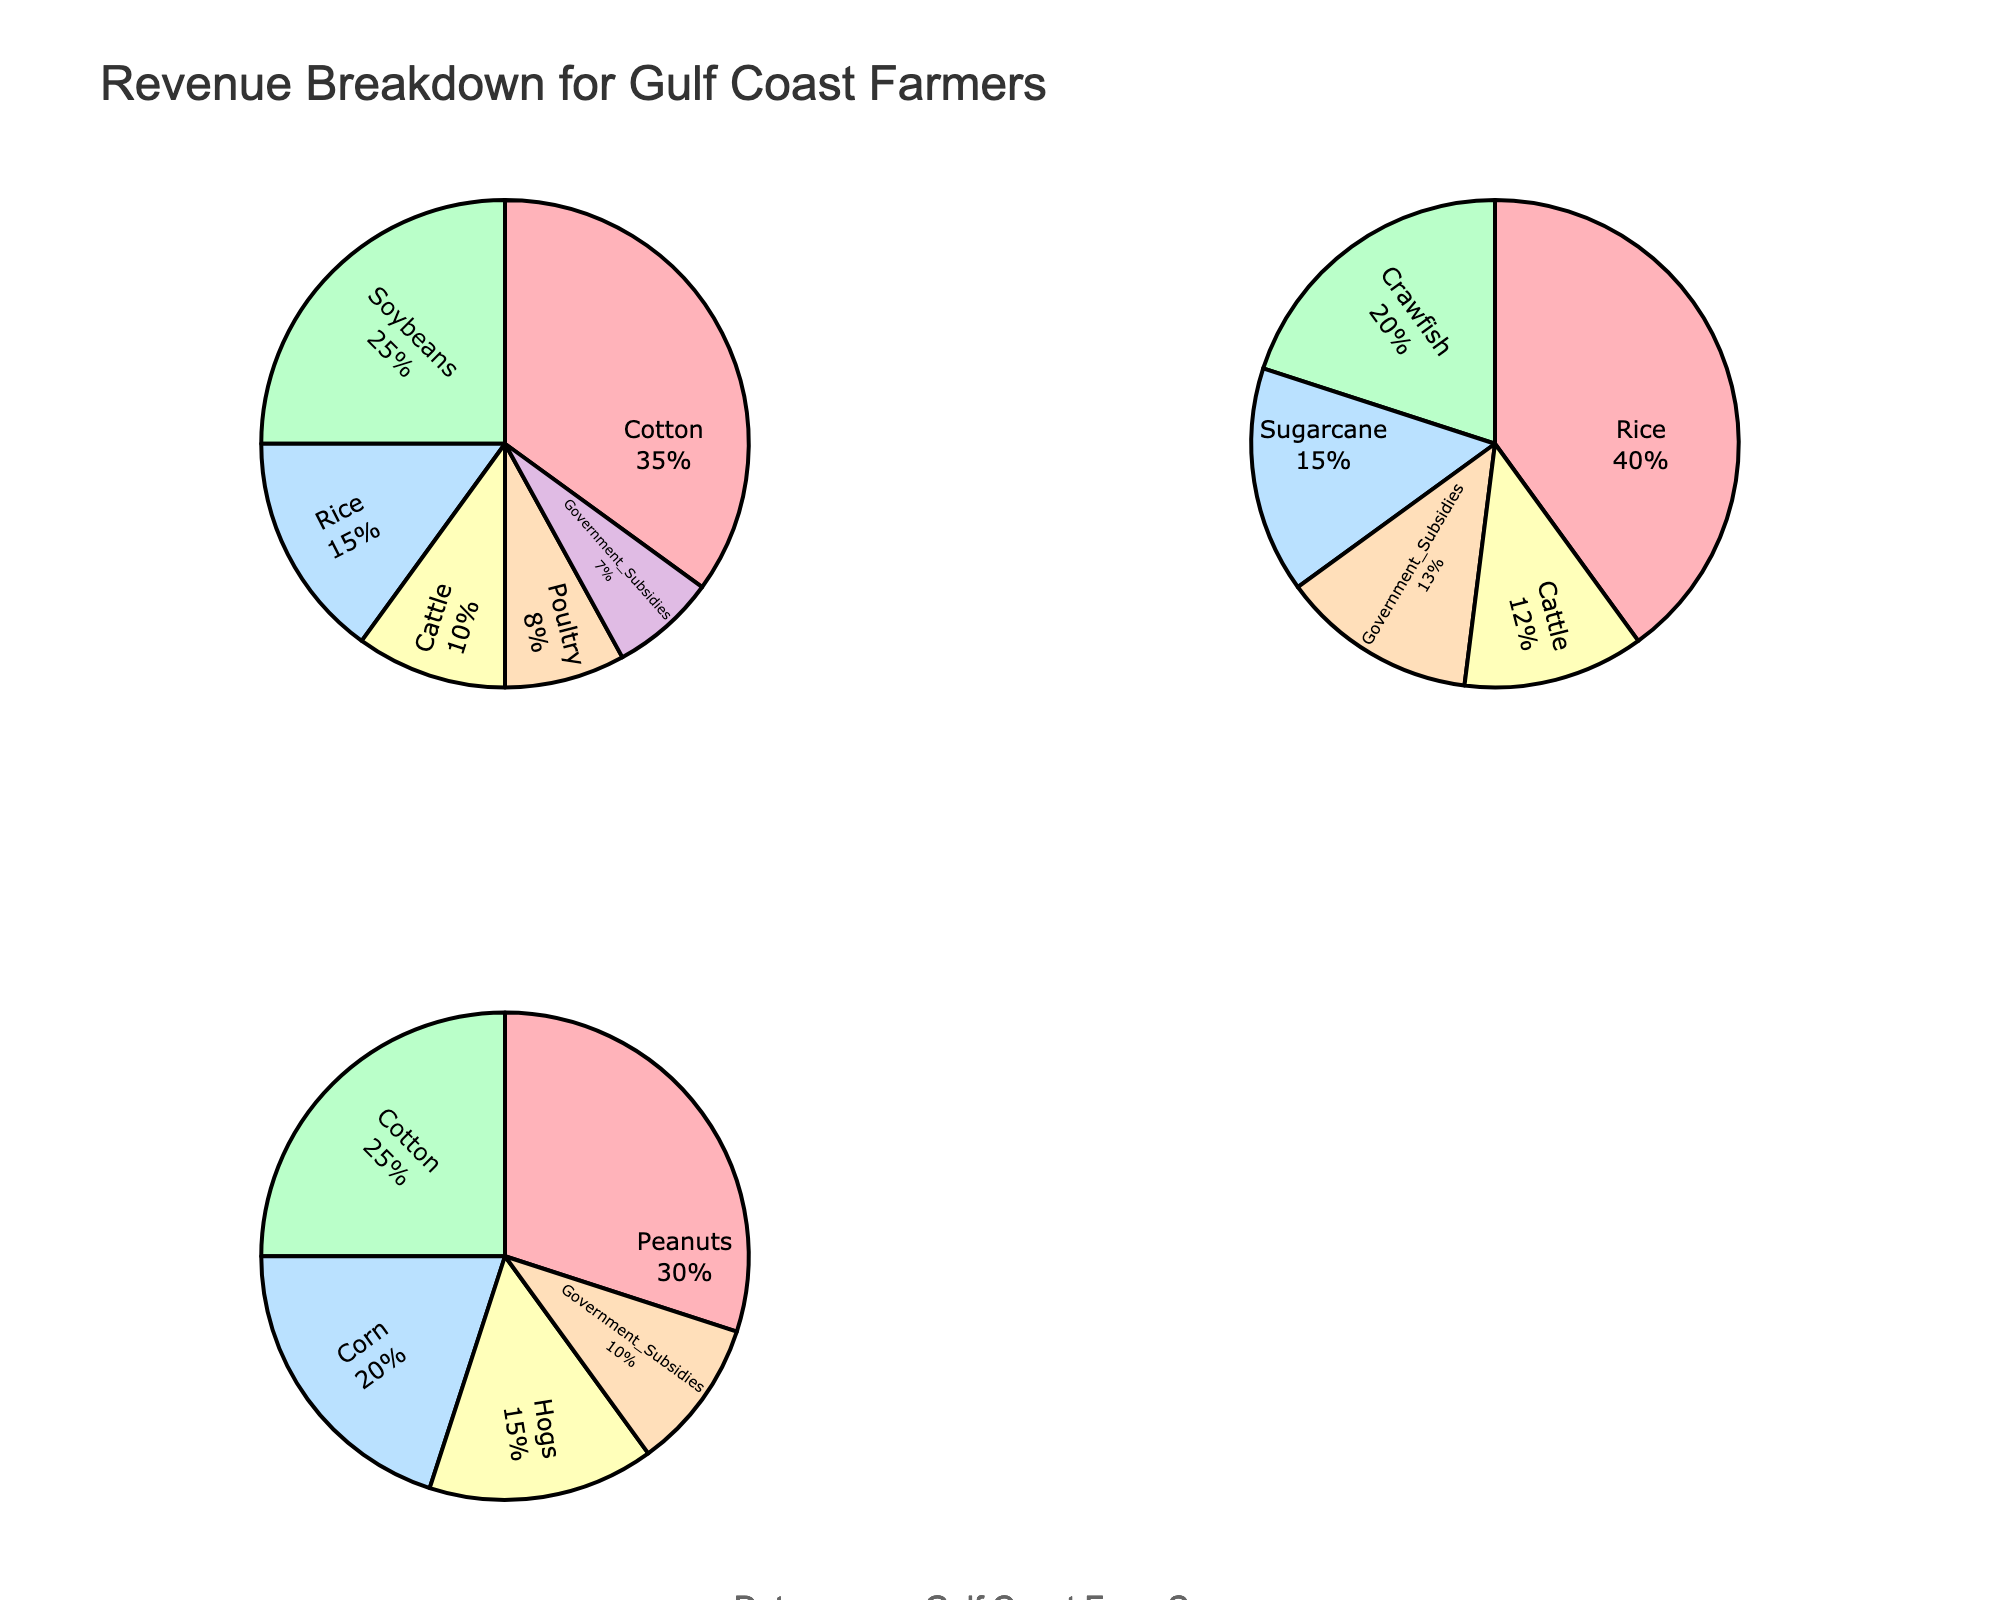What is the title of the figure? The title is displayed at the top of the figure, and it reads "Revenue Breakdown for Gulf Coast Farmers".
Answer: Revenue Breakdown for Gulf Coast Farmers Which farmer has the highest percentage of government subsidies in their revenue? By examining the pie charts, the government subsidies percentage is shown for each farmer. Johnson's pie chart shows 13% for government subsidies, which is the highest among all farmers.
Answer: Johnson How much of Smith's revenue comes from livestock (Cattle and Poultry combined)? Adding the percentages for Cattle (10%) and Poultry (8%) from Smith's pie chart gives 10% + 8% = 18%.
Answer: 18% Which crop contributes the most to Davis's revenue? By looking at Davis's pie chart, we can see that Peanuts contribute 30%, which is the highest among all categories.
Answer: Peanuts What's the combined percentage of revenue from Soybeans and Rice for Smith? Soybeans contribute 25% and Rice contributes 15%. Adding them together gives 25% + 15% = 40%.
Answer: 40% Is Johnson more reliant on rice or crawfish for his revenue? Johnson's pie chart shows Rice contributing 40% and Crawfish contributing 20%. Since 40% is greater than 20%, Johnson is more reliant on Rice.
Answer: Rice Compare the percentage of Cotton revenue between Smith and Davis. Smith's pie chart shows Cotton at 35%, and Davis's pie chart shows Cotton at 25%. Therefore, Smith has a higher percentage for Cotton.
Answer: Smith Does any farmer derive more than 50% of their revenue from a single source? By examining each pie chart, none of the farmers have a single revenue source exceeding 50%. The highest is 40% from Rice for Johnson.
Answer: No Which farmer has the most diversified revenue sources? To determine diversification, we look at how evenly the revenue percentages are spread across different sources. Smith has several sources close in percentage (35%, 25%, 15%, 10%, 8%, 7%), indicating more diversification compared to others.
Answer: Smith 